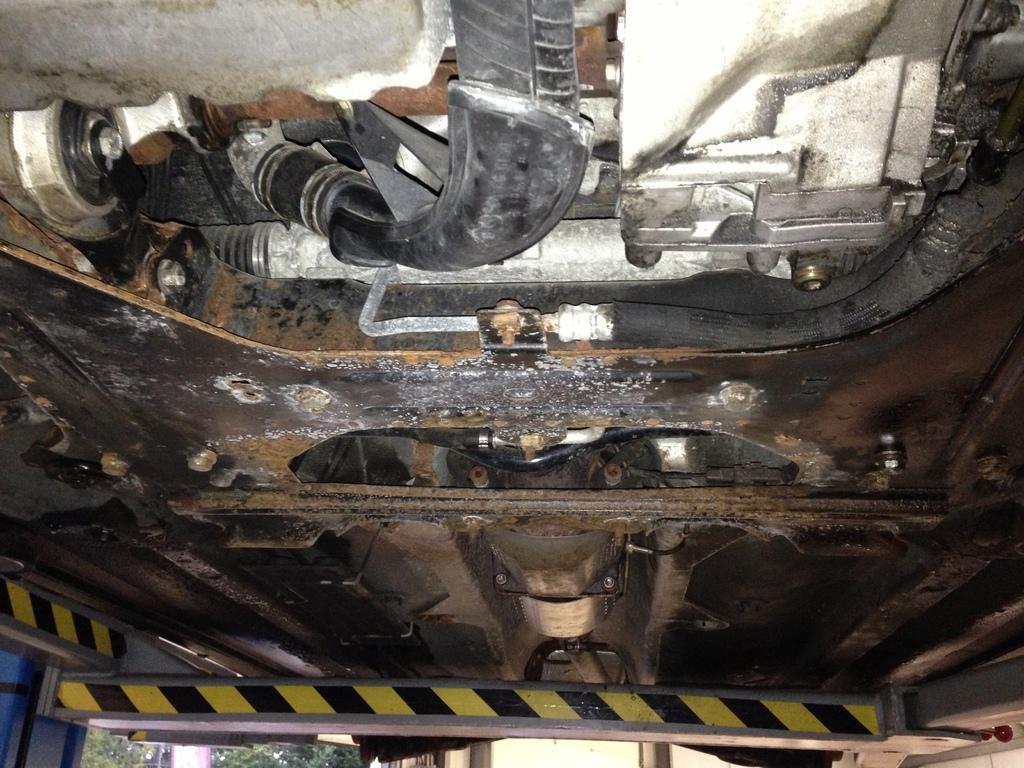Can you describe this image briefly? This is the image of a vehicle from below of the engine. 